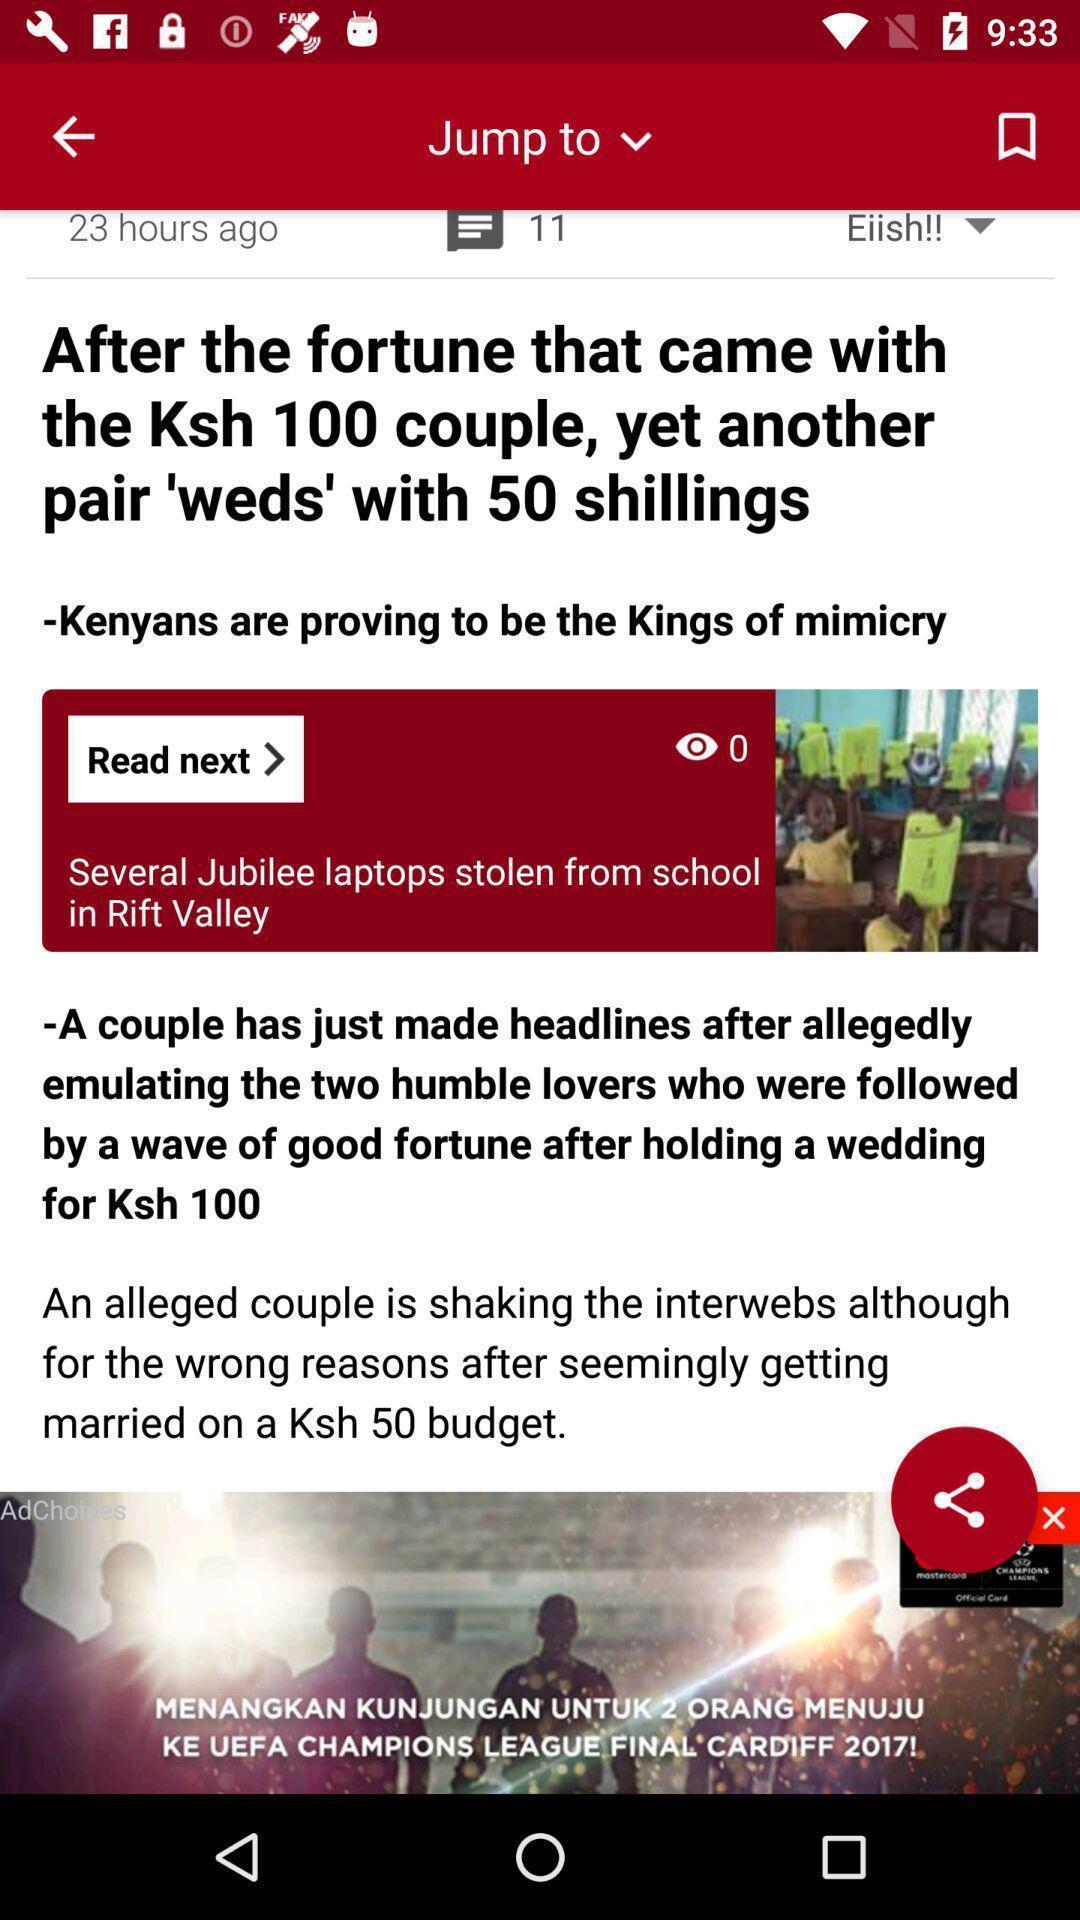Provide a description of this screenshot. Screen displaying the page of a news app. 